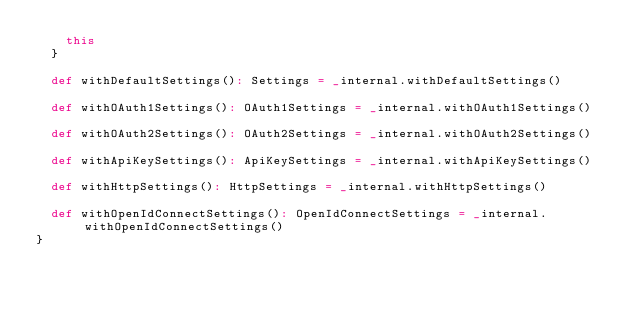<code> <loc_0><loc_0><loc_500><loc_500><_Scala_>    this
  }

  def withDefaultSettings(): Settings = _internal.withDefaultSettings()

  def withOAuth1Settings(): OAuth1Settings = _internal.withOAuth1Settings()

  def withOAuth2Settings(): OAuth2Settings = _internal.withOAuth2Settings()

  def withApiKeySettings(): ApiKeySettings = _internal.withApiKeySettings()

  def withHttpSettings(): HttpSettings = _internal.withHttpSettings()

  def withOpenIdConnectSettings(): OpenIdConnectSettings = _internal.withOpenIdConnectSettings()
}
</code> 